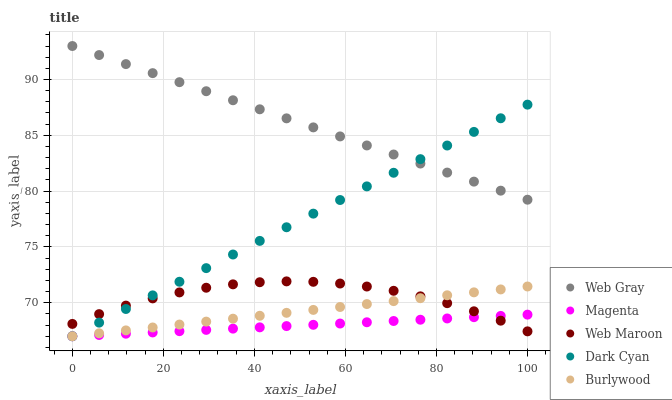Does Magenta have the minimum area under the curve?
Answer yes or no. Yes. Does Web Gray have the maximum area under the curve?
Answer yes or no. Yes. Does Burlywood have the minimum area under the curve?
Answer yes or no. No. Does Burlywood have the maximum area under the curve?
Answer yes or no. No. Is Dark Cyan the smoothest?
Answer yes or no. Yes. Is Web Maroon the roughest?
Answer yes or no. Yes. Is Burlywood the smoothest?
Answer yes or no. No. Is Burlywood the roughest?
Answer yes or no. No. Does Dark Cyan have the lowest value?
Answer yes or no. Yes. Does Web Gray have the lowest value?
Answer yes or no. No. Does Web Gray have the highest value?
Answer yes or no. Yes. Does Burlywood have the highest value?
Answer yes or no. No. Is Magenta less than Web Gray?
Answer yes or no. Yes. Is Web Gray greater than Burlywood?
Answer yes or no. Yes. Does Web Maroon intersect Dark Cyan?
Answer yes or no. Yes. Is Web Maroon less than Dark Cyan?
Answer yes or no. No. Is Web Maroon greater than Dark Cyan?
Answer yes or no. No. Does Magenta intersect Web Gray?
Answer yes or no. No. 